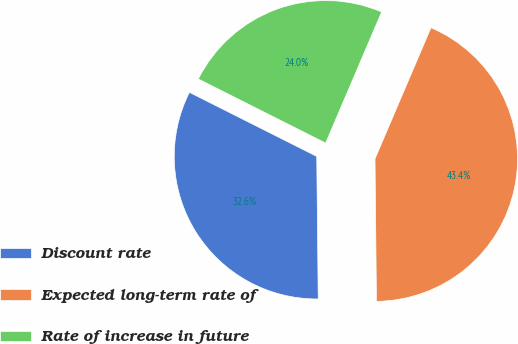Convert chart. <chart><loc_0><loc_0><loc_500><loc_500><pie_chart><fcel>Discount rate<fcel>Expected long-term rate of<fcel>Rate of increase in future<nl><fcel>32.58%<fcel>43.41%<fcel>24.0%<nl></chart> 